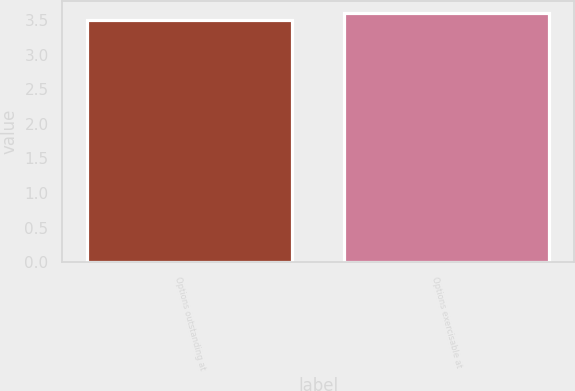<chart> <loc_0><loc_0><loc_500><loc_500><bar_chart><fcel>Options outstanding at<fcel>Options exercisable at<nl><fcel>3.5<fcel>3.6<nl></chart> 